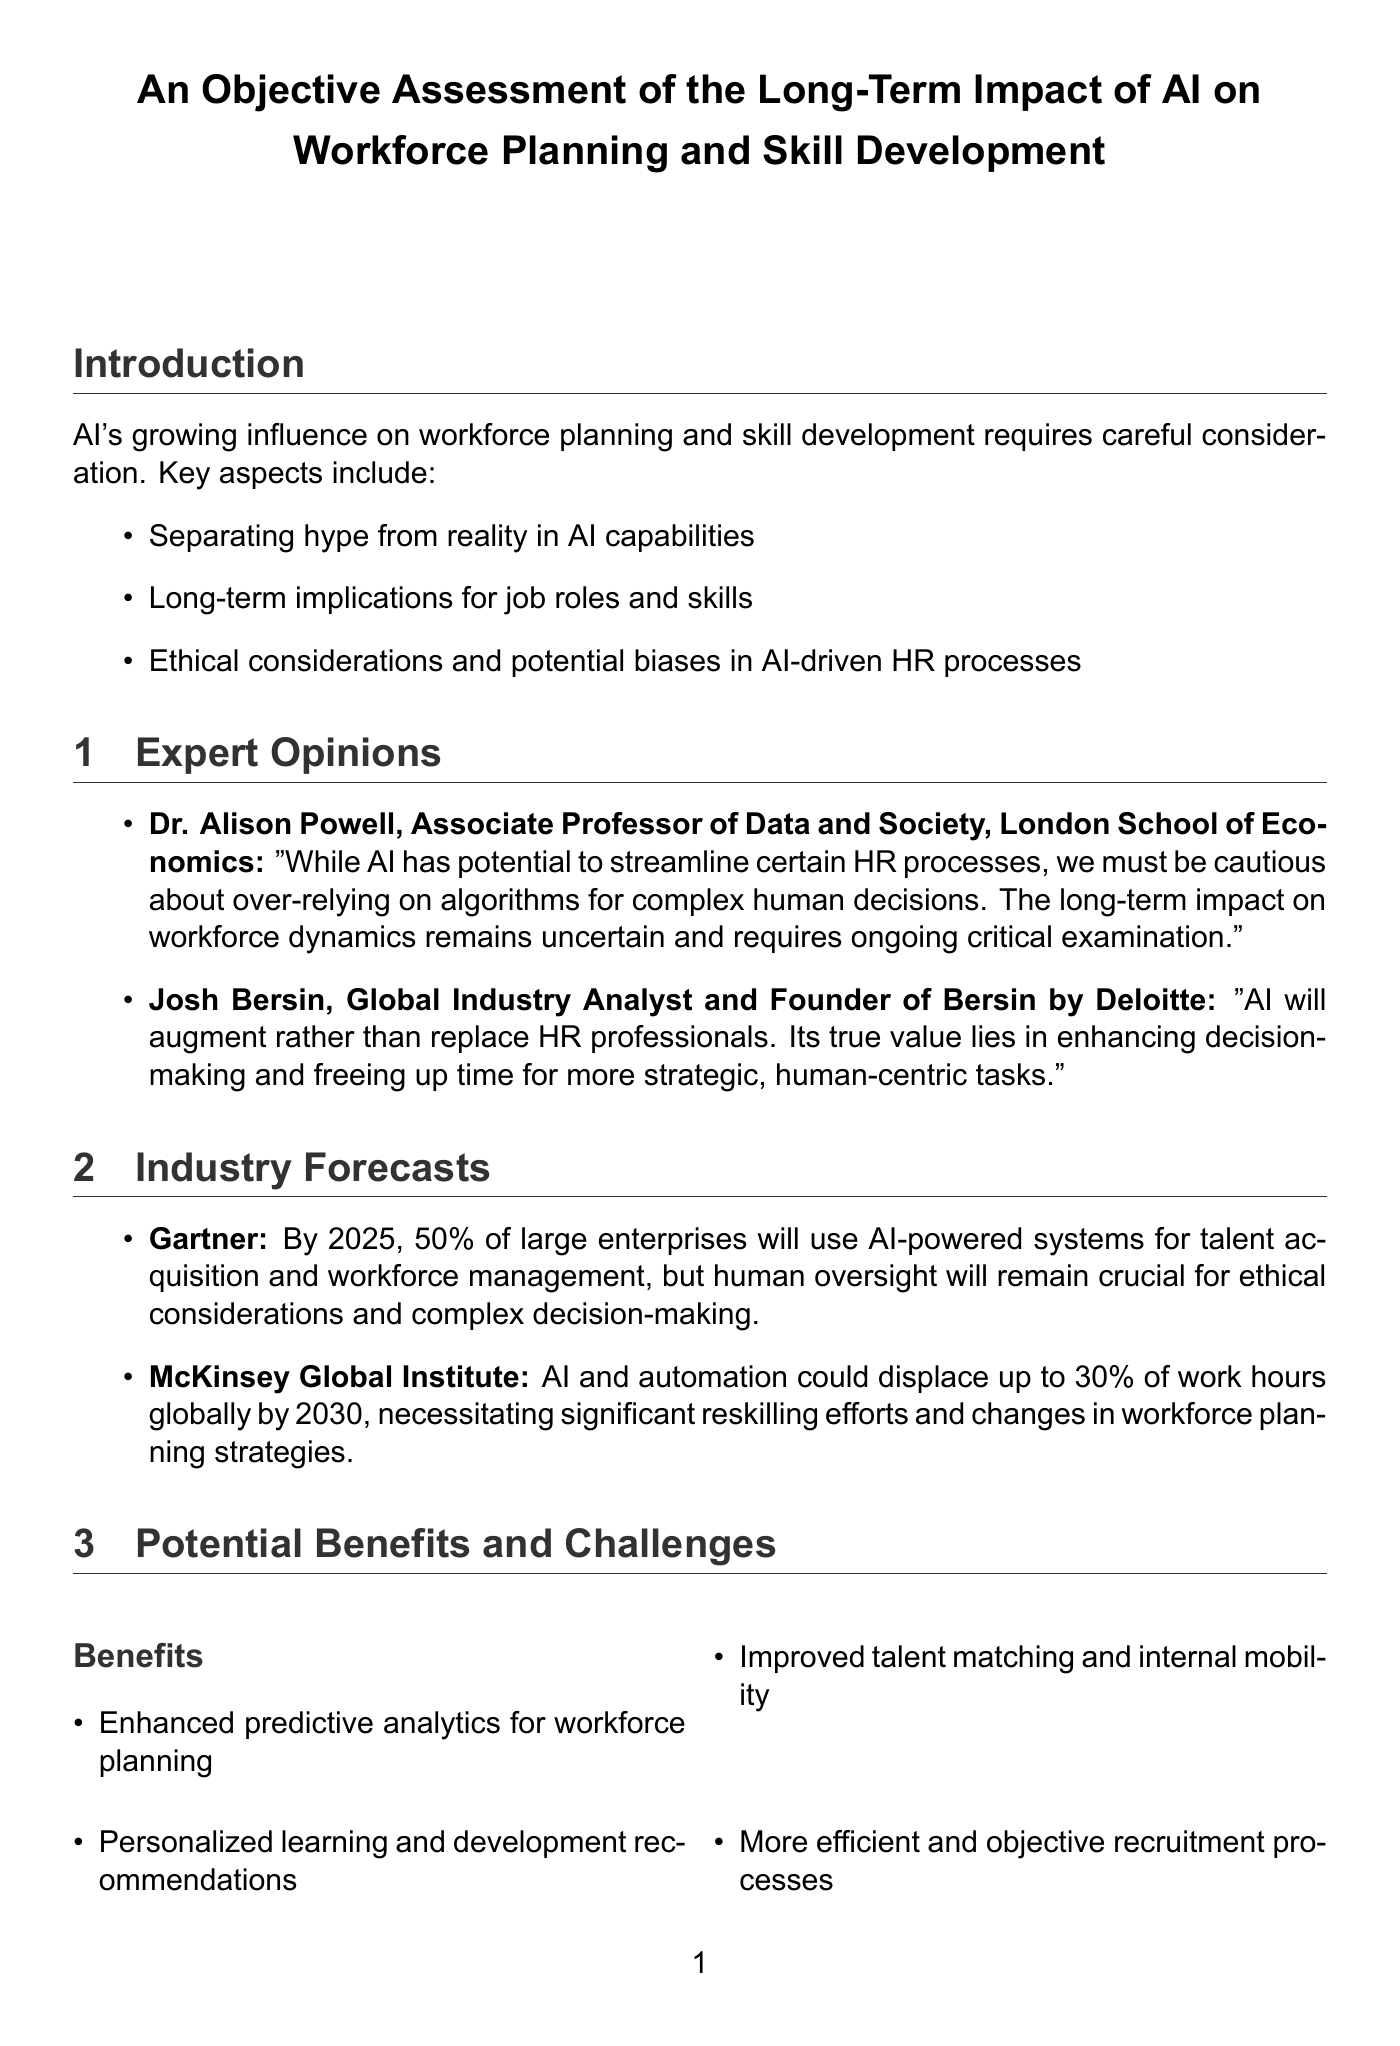What is the key consideration related to AI's impact on HR? The document lists key considerations including separating hype from reality, implications for job roles, and ethical considerations.
Answer: Separating hype from reality in AI capabilities Who is the author of the opinion stating that AI will augment rather than replace HR professionals? This is attributed to Josh Bersin, a global industry analyst.
Answer: Josh Bersin What percentage of large enterprises is predicted to use AI-powered systems by 2025 according to Gartner? This figure highlights Gartner's forecast regarding AI integration in large enterprises.
Answer: 50% Which company implemented AI-powered skills inference? The case studies include specific companies that implemented AI initiatives.
Answer: IBM What is a mentioned benefit of using AI in HR processes? The document highlights various benefits associated with AI in workforce planning.
Answer: Enhanced predictive analytics for workforce planning What is one challenge associated with AI implementation in HR? The document identifies risks involved in the use of AI, such as algorithmic bias.
Answer: Potential for algorithmic bias in hiring and promotion decisions Which skill set is emphasized as necessary in the context of AI advancements? This question targets the implications for skill development based on the report's findings.
Answer: Hybrid skill sets combining technical and soft skills Who provided a cautionary opinion about relying too much on AI for human decisions? This question pertains to the expert opinions outlined in the document.
Answer: Dr. Alison Powell What recommendation is given to HR professionals regarding AI? This question focuses on actionable advice derived from the report.
Answer: Maintain a balance between AI-driven insights and human judgment in decision-making 